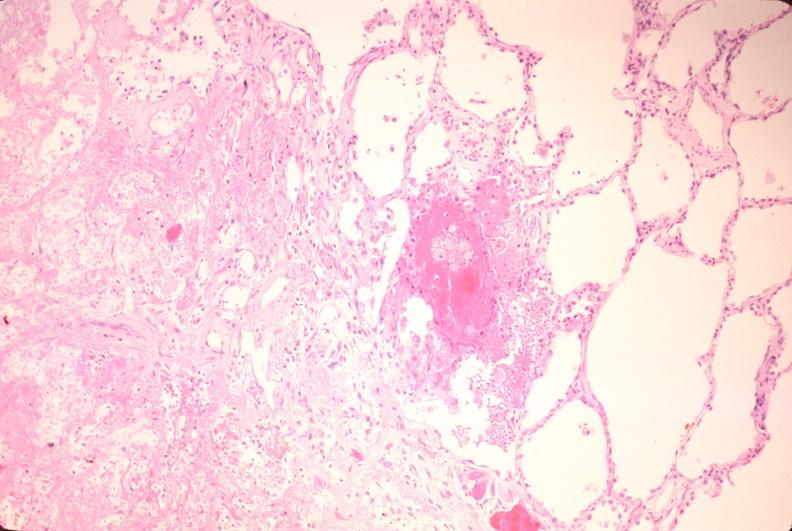what does this image show?
Answer the question using a single word or phrase. Lung 